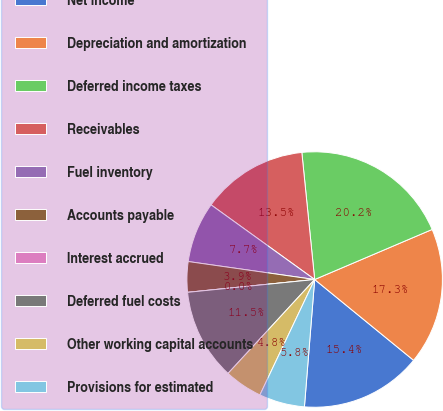Convert chart. <chart><loc_0><loc_0><loc_500><loc_500><pie_chart><fcel>Net income<fcel>Depreciation and amortization<fcel>Deferred income taxes<fcel>Receivables<fcel>Fuel inventory<fcel>Accounts payable<fcel>Interest accrued<fcel>Deferred fuel costs<fcel>Other working capital accounts<fcel>Provisions for estimated<nl><fcel>15.38%<fcel>17.31%<fcel>20.19%<fcel>13.46%<fcel>7.69%<fcel>3.85%<fcel>0.0%<fcel>11.54%<fcel>4.81%<fcel>5.77%<nl></chart> 